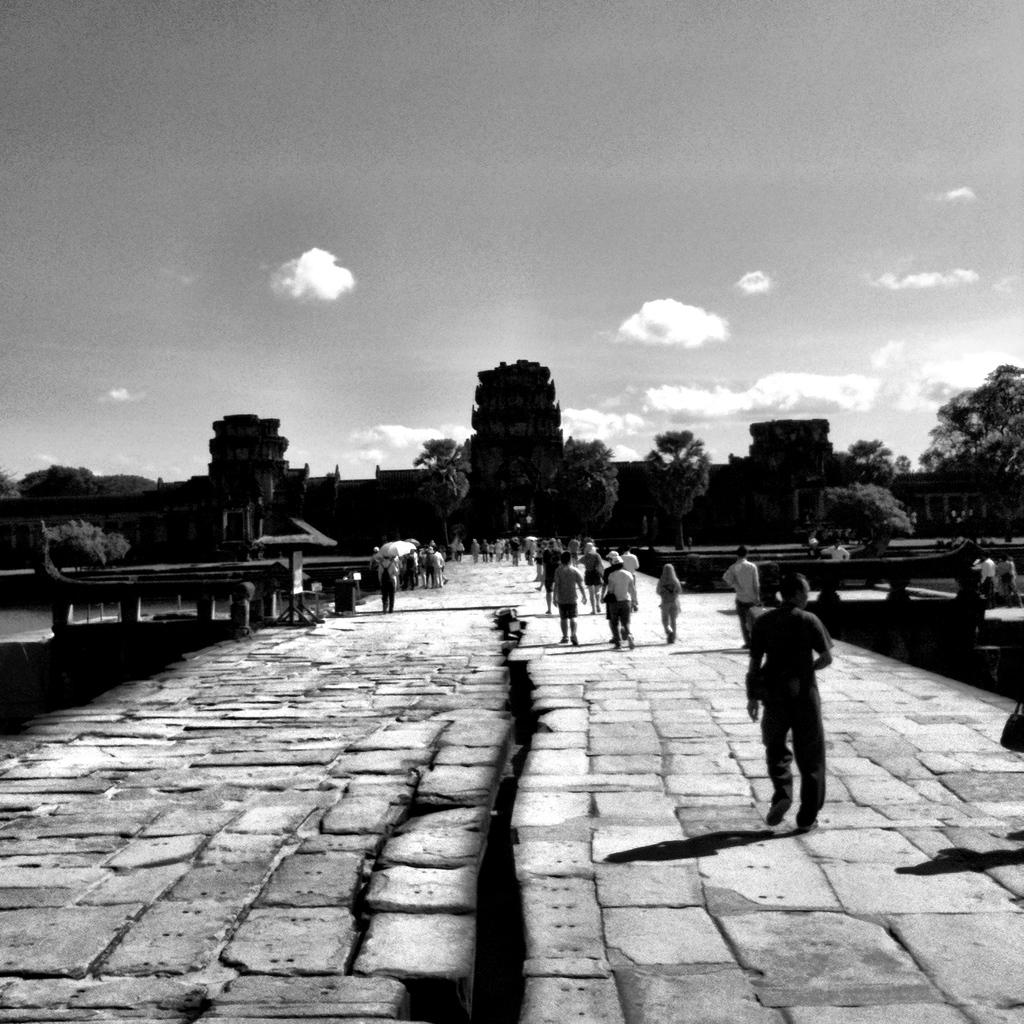What are the people in the image doing? The people in the image are walking. What can be seen in the background of the image? There are trees and a building in the background of the image. What is the condition of the sky in the image? The sky is clear in the image. What is the color scheme of the image? The image is black and white. What type of polish is being applied to the head in the image? There is no polish or head present in the image; it features people walking in a black and white setting. 